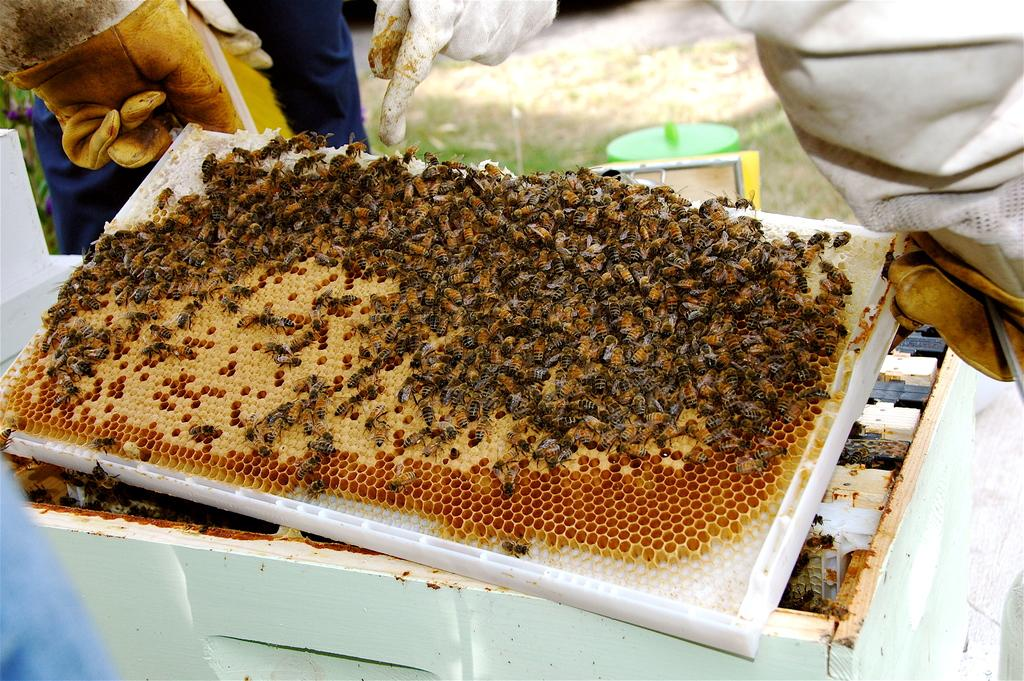What is present in the image? There is a person in the image. What is the person holding? The person is holding an object. What can be seen on the object? The object has honey bees on it. How many cushions are visible in the image? There are no cushions present in the image. Are there any bikes or bridges visible in the image? No, there are no bikes or bridges present in the image. 